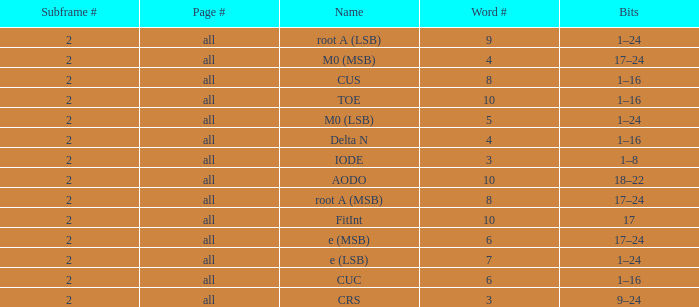What is the total subframe count with Bits of 18–22? 2.0. 